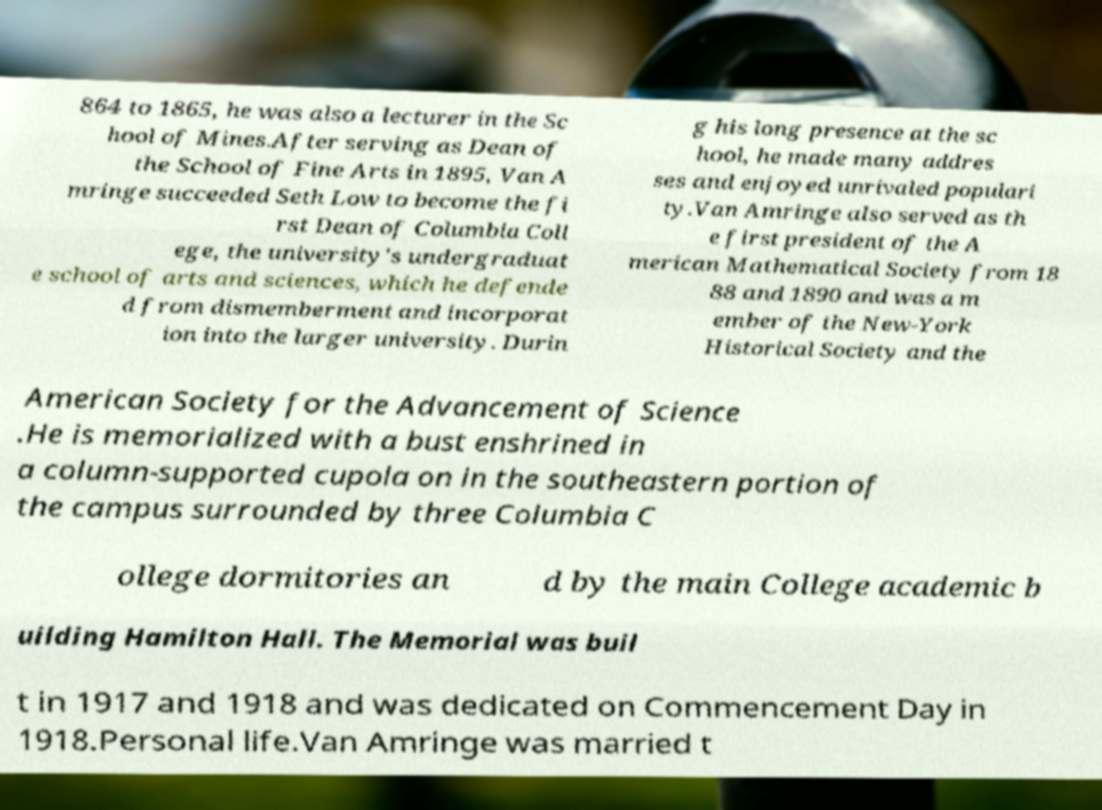Could you extract and type out the text from this image? 864 to 1865, he was also a lecturer in the Sc hool of Mines.After serving as Dean of the School of Fine Arts in 1895, Van A mringe succeeded Seth Low to become the fi rst Dean of Columbia Coll ege, the university's undergraduat e school of arts and sciences, which he defende d from dismemberment and incorporat ion into the larger university. Durin g his long presence at the sc hool, he made many addres ses and enjoyed unrivaled populari ty.Van Amringe also served as th e first president of the A merican Mathematical Society from 18 88 and 1890 and was a m ember of the New-York Historical Society and the American Society for the Advancement of Science .He is memorialized with a bust enshrined in a column-supported cupola on in the southeastern portion of the campus surrounded by three Columbia C ollege dormitories an d by the main College academic b uilding Hamilton Hall. The Memorial was buil t in 1917 and 1918 and was dedicated on Commencement Day in 1918.Personal life.Van Amringe was married t 